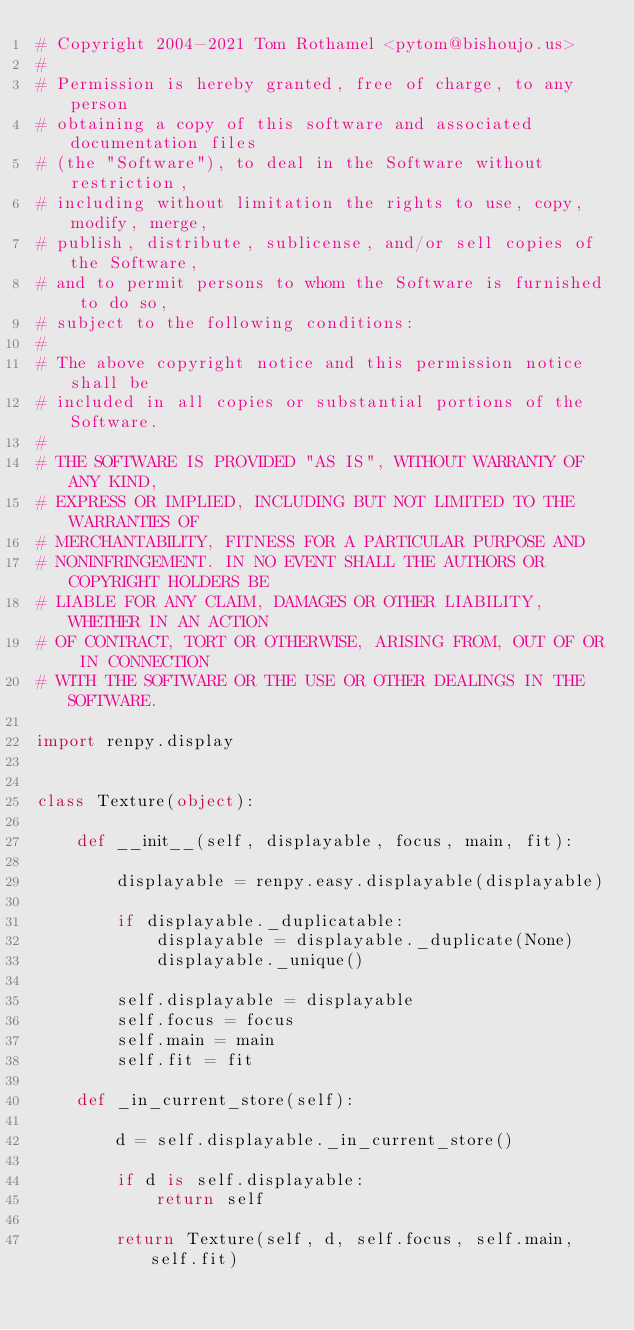<code> <loc_0><loc_0><loc_500><loc_500><_Python_># Copyright 2004-2021 Tom Rothamel <pytom@bishoujo.us>
#
# Permission is hereby granted, free of charge, to any person
# obtaining a copy of this software and associated documentation files
# (the "Software"), to deal in the Software without restriction,
# including without limitation the rights to use, copy, modify, merge,
# publish, distribute, sublicense, and/or sell copies of the Software,
# and to permit persons to whom the Software is furnished to do so,
# subject to the following conditions:
#
# The above copyright notice and this permission notice shall be
# included in all copies or substantial portions of the Software.
#
# THE SOFTWARE IS PROVIDED "AS IS", WITHOUT WARRANTY OF ANY KIND,
# EXPRESS OR IMPLIED, INCLUDING BUT NOT LIMITED TO THE WARRANTIES OF
# MERCHANTABILITY, FITNESS FOR A PARTICULAR PURPOSE AND
# NONINFRINGEMENT. IN NO EVENT SHALL THE AUTHORS OR COPYRIGHT HOLDERS BE
# LIABLE FOR ANY CLAIM, DAMAGES OR OTHER LIABILITY, WHETHER IN AN ACTION
# OF CONTRACT, TORT OR OTHERWISE, ARISING FROM, OUT OF OR IN CONNECTION
# WITH THE SOFTWARE OR THE USE OR OTHER DEALINGS IN THE SOFTWARE.

import renpy.display


class Texture(object):

    def __init__(self, displayable, focus, main, fit):

        displayable = renpy.easy.displayable(displayable)

        if displayable._duplicatable:
            displayable = displayable._duplicate(None)
            displayable._unique()

        self.displayable = displayable
        self.focus = focus
        self.main = main
        self.fit = fit

    def _in_current_store(self):

        d = self.displayable._in_current_store()

        if d is self.displayable:
            return self

        return Texture(self, d, self.focus, self.main, self.fit)

</code> 